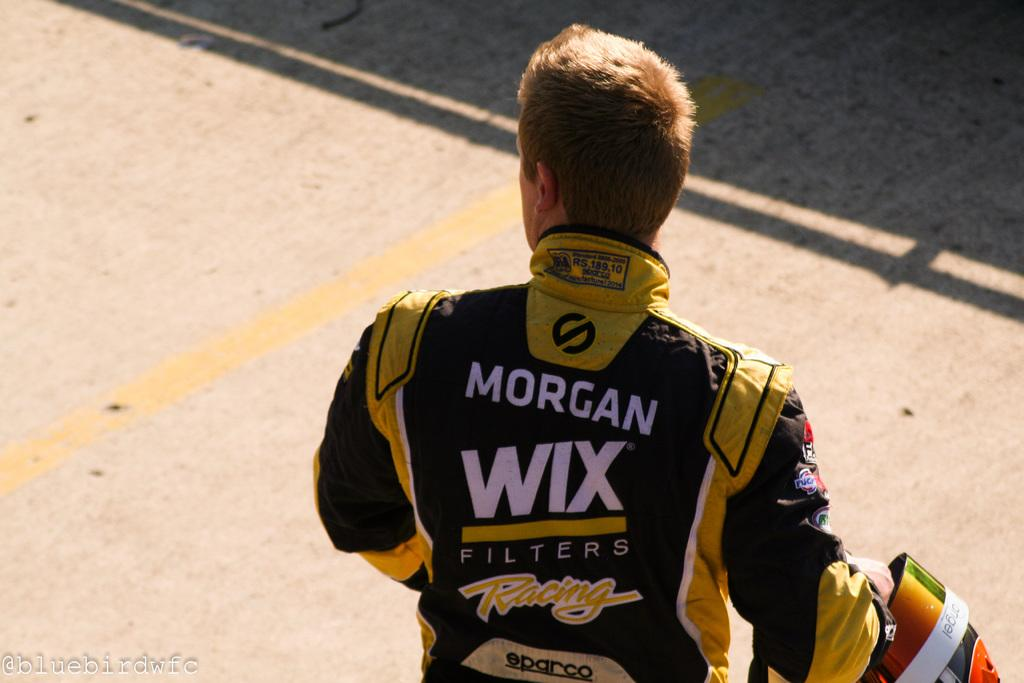Provide a one-sentence caption for the provided image. A racing driver wearing a uniform sponsored by Wix Filters. 